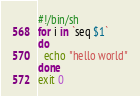Convert code to text. <code><loc_0><loc_0><loc_500><loc_500><_Bash_>#!/bin/sh
for i in `seq $1`
do
  echo "hello world"
done
exit 0
</code> 